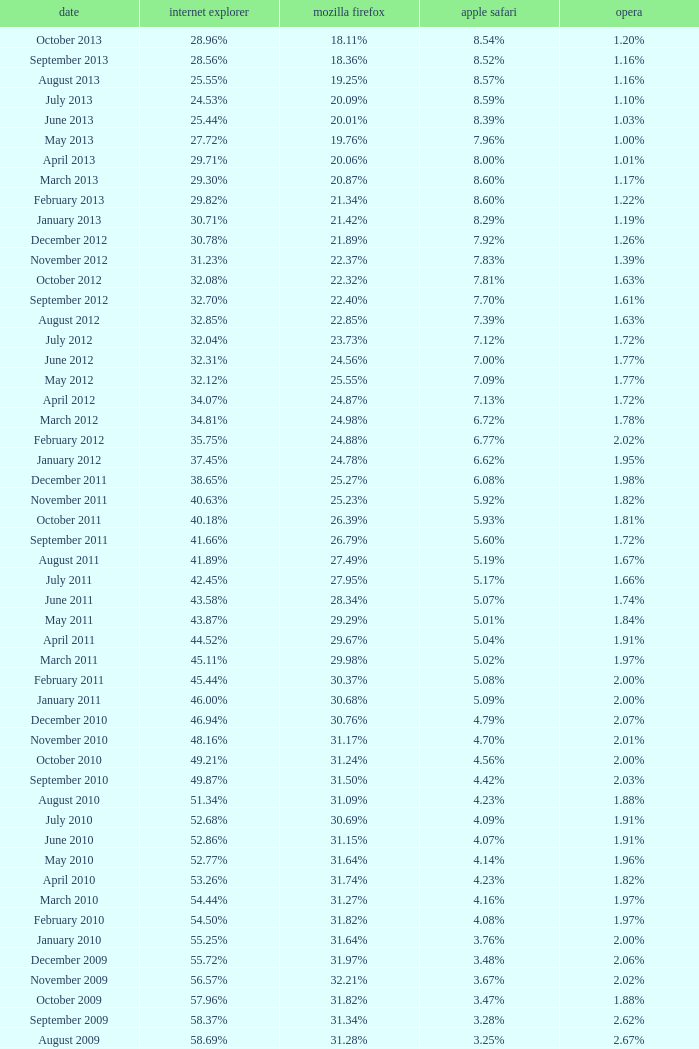What percentage of browsers were using Internet Explorer in April 2009? 61.88%. 